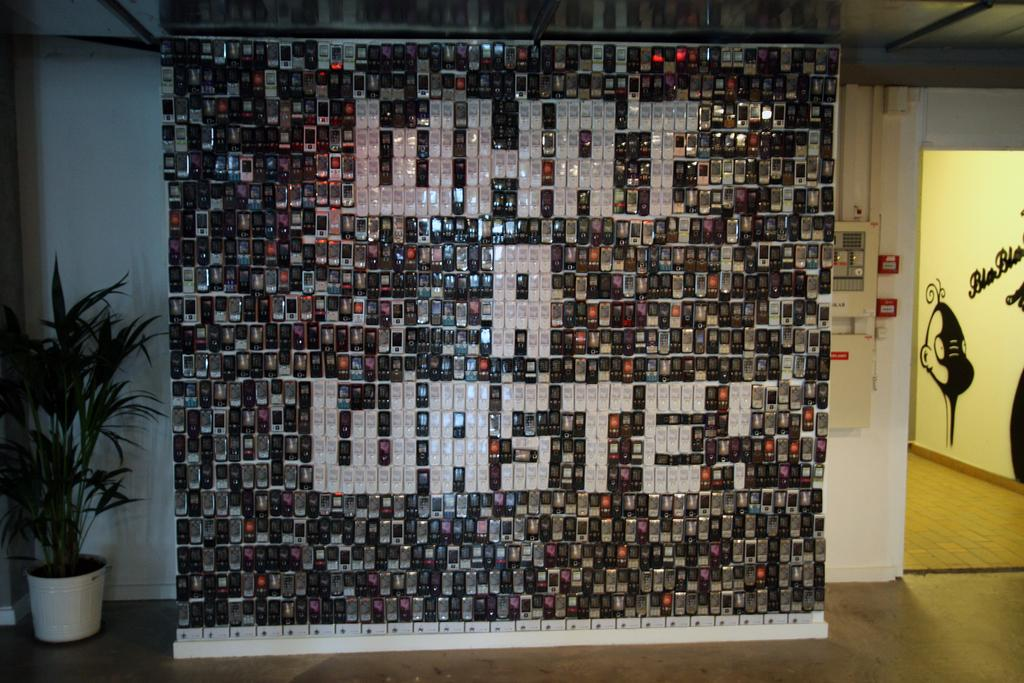<image>
Relay a brief, clear account of the picture shown. a wall of many cell phones with the message What a waste in them 